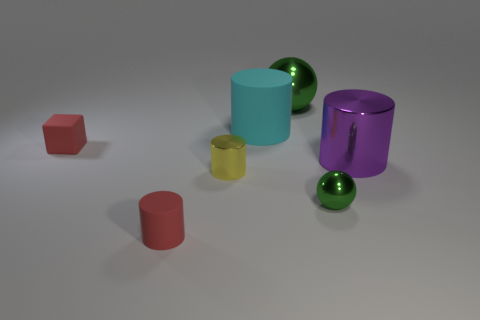Subtract 1 cylinders. How many cylinders are left? 3 Add 1 large spheres. How many objects exist? 8 Subtract all cubes. How many objects are left? 6 Add 7 small metal things. How many small metal things exist? 9 Subtract 0 blue cubes. How many objects are left? 7 Subtract all small shiny things. Subtract all purple cylinders. How many objects are left? 4 Add 2 tiny green balls. How many tiny green balls are left? 3 